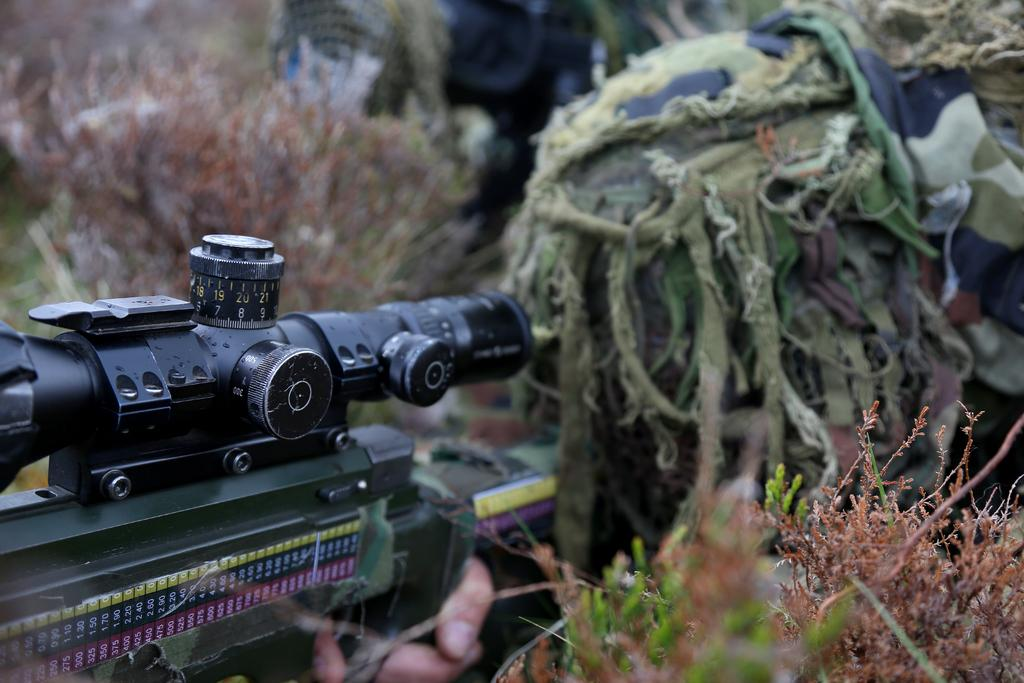What is the person in the image holding? The person in the image is holding a weapon. Can you describe the background of the image? The background of the image is blurred. What type of living organisms can be seen in the image? Plants are visible in the image. What type of cough medicine is the person taking in the image? There is no indication of cough medicine or any medical activity in the image. 